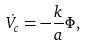Convert formula to latex. <formula><loc_0><loc_0><loc_500><loc_500>\dot { V _ { c } } = - \frac { k } { a } \Phi ,</formula> 